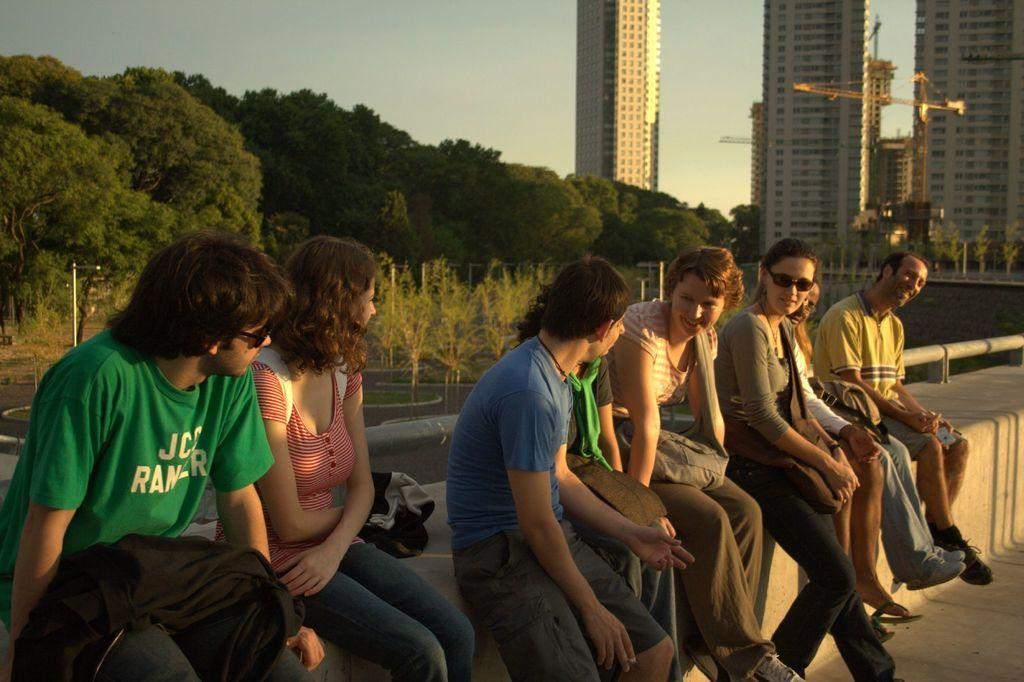What are the people in the image doing? The people in the image are sitting on a wall. What can be seen in the background of the image? There are buildings, trees, and the sky visible in the background of the image. What other objects are present in the image? There are poles in the image. How many jellyfish can be seen swimming in the sky in the image? There are no jellyfish present in the image, and the sky is not a suitable environment for jellyfish. 